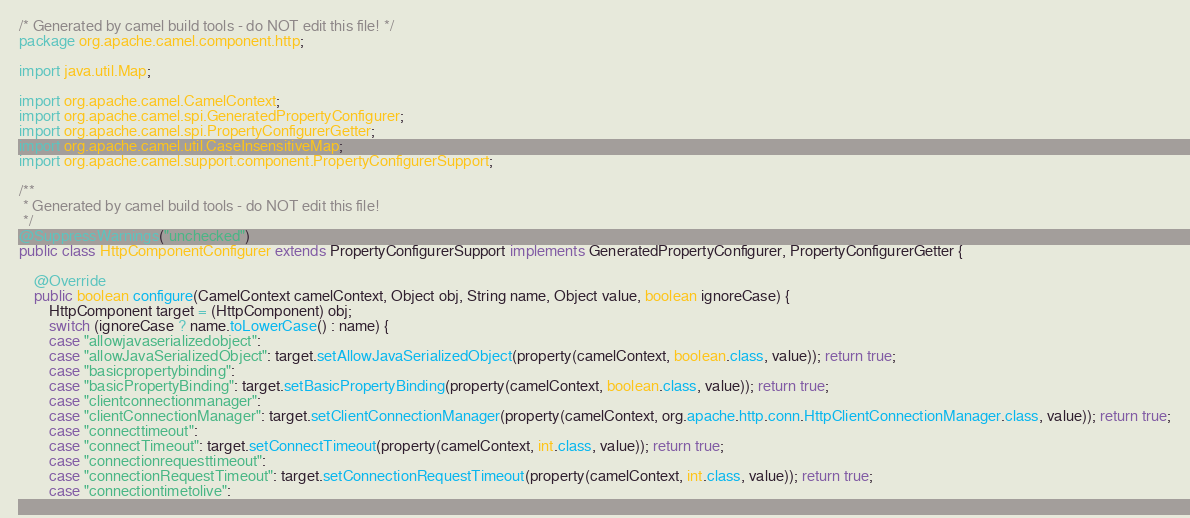Convert code to text. <code><loc_0><loc_0><loc_500><loc_500><_Java_>/* Generated by camel build tools - do NOT edit this file! */
package org.apache.camel.component.http;

import java.util.Map;

import org.apache.camel.CamelContext;
import org.apache.camel.spi.GeneratedPropertyConfigurer;
import org.apache.camel.spi.PropertyConfigurerGetter;
import org.apache.camel.util.CaseInsensitiveMap;
import org.apache.camel.support.component.PropertyConfigurerSupport;

/**
 * Generated by camel build tools - do NOT edit this file!
 */
@SuppressWarnings("unchecked")
public class HttpComponentConfigurer extends PropertyConfigurerSupport implements GeneratedPropertyConfigurer, PropertyConfigurerGetter {

    @Override
    public boolean configure(CamelContext camelContext, Object obj, String name, Object value, boolean ignoreCase) {
        HttpComponent target = (HttpComponent) obj;
        switch (ignoreCase ? name.toLowerCase() : name) {
        case "allowjavaserializedobject":
        case "allowJavaSerializedObject": target.setAllowJavaSerializedObject(property(camelContext, boolean.class, value)); return true;
        case "basicpropertybinding":
        case "basicPropertyBinding": target.setBasicPropertyBinding(property(camelContext, boolean.class, value)); return true;
        case "clientconnectionmanager":
        case "clientConnectionManager": target.setClientConnectionManager(property(camelContext, org.apache.http.conn.HttpClientConnectionManager.class, value)); return true;
        case "connecttimeout":
        case "connectTimeout": target.setConnectTimeout(property(camelContext, int.class, value)); return true;
        case "connectionrequesttimeout":
        case "connectionRequestTimeout": target.setConnectionRequestTimeout(property(camelContext, int.class, value)); return true;
        case "connectiontimetolive":</code> 